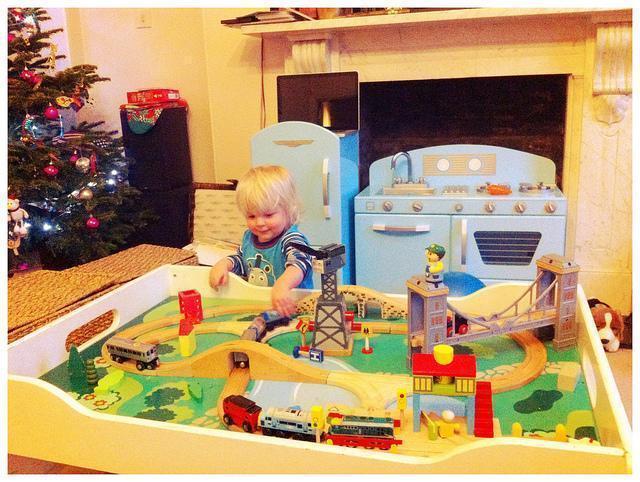What is the child playing with?
Select the accurate response from the four choices given to answer the question.
Options: Dog, train, egg, cat. Train. 